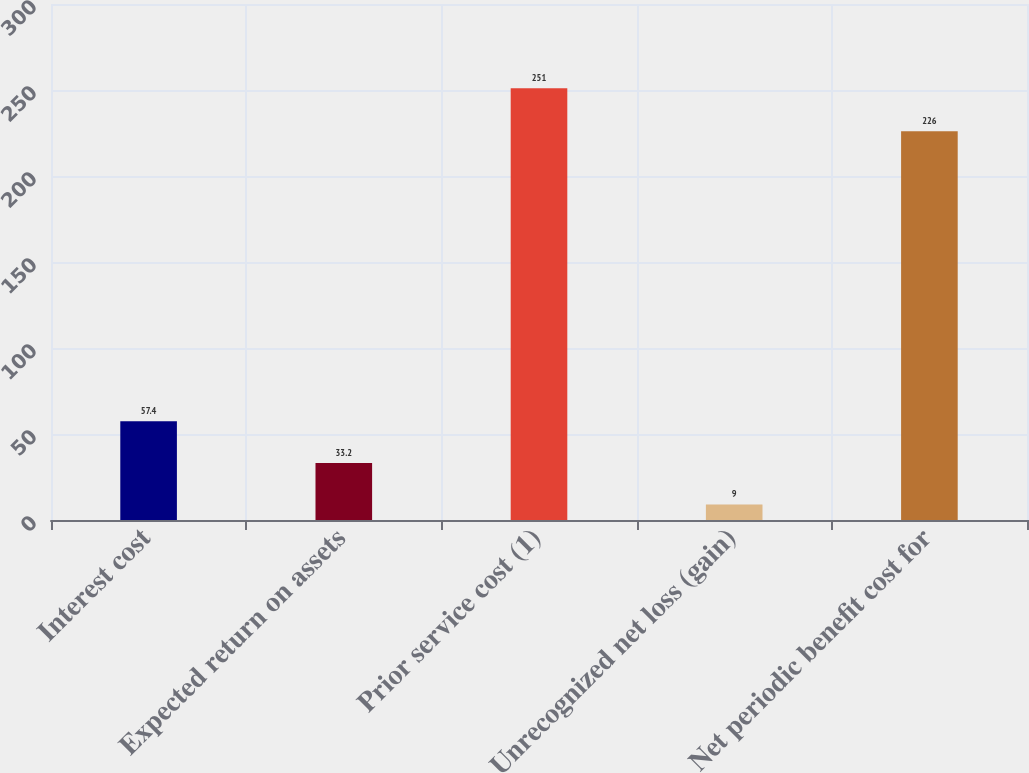<chart> <loc_0><loc_0><loc_500><loc_500><bar_chart><fcel>Interest cost<fcel>Expected return on assets<fcel>Prior service cost (1)<fcel>Unrecognized net loss (gain)<fcel>Net periodic benefit cost for<nl><fcel>57.4<fcel>33.2<fcel>251<fcel>9<fcel>226<nl></chart> 